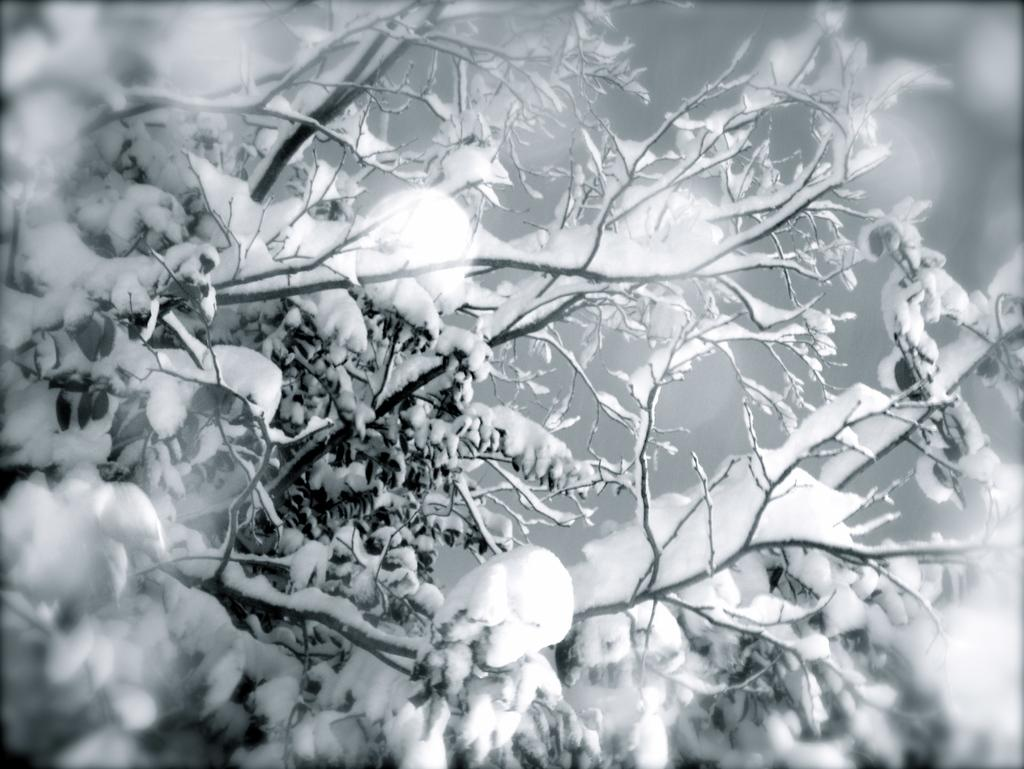What type of weather condition is depicted in the image? There is snow on a tree in the image, which suggests a cold or wintery weather condition. What type of jeans is the tree wearing in the image? Trees do not wear jeans, as they are not human beings or living organisms that wear clothing. 